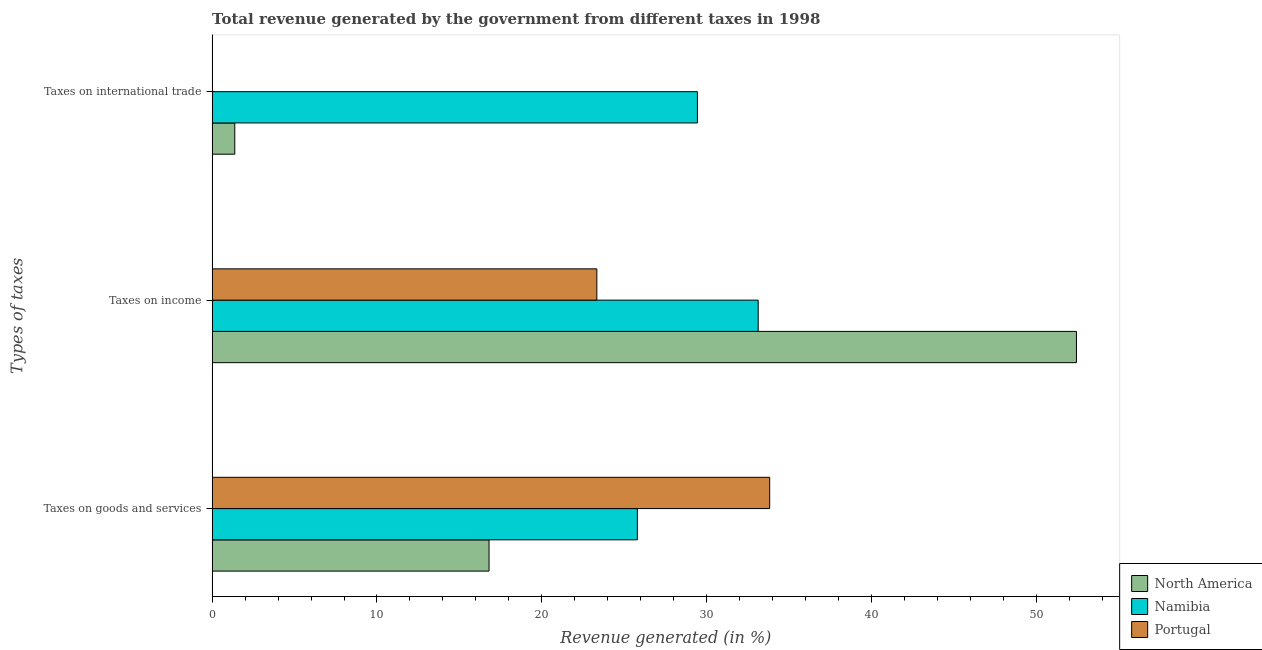Are the number of bars per tick equal to the number of legend labels?
Ensure brevity in your answer.  Yes. Are the number of bars on each tick of the Y-axis equal?
Keep it short and to the point. Yes. How many bars are there on the 3rd tick from the top?
Keep it short and to the point. 3. How many bars are there on the 2nd tick from the bottom?
Offer a very short reply. 3. What is the label of the 1st group of bars from the top?
Ensure brevity in your answer.  Taxes on international trade. What is the percentage of revenue generated by taxes on income in North America?
Provide a short and direct response. 52.43. Across all countries, what is the maximum percentage of revenue generated by tax on international trade?
Your answer should be compact. 29.44. Across all countries, what is the minimum percentage of revenue generated by taxes on goods and services?
Provide a succinct answer. 16.8. What is the total percentage of revenue generated by taxes on income in the graph?
Provide a succinct answer. 108.89. What is the difference between the percentage of revenue generated by taxes on income in North America and that in Portugal?
Offer a very short reply. 29.09. What is the difference between the percentage of revenue generated by tax on international trade in Namibia and the percentage of revenue generated by taxes on income in Portugal?
Keep it short and to the point. 6.1. What is the average percentage of revenue generated by taxes on goods and services per country?
Give a very brief answer. 25.47. What is the difference between the percentage of revenue generated by taxes on income and percentage of revenue generated by taxes on goods and services in Portugal?
Give a very brief answer. -10.49. In how many countries, is the percentage of revenue generated by taxes on income greater than 24 %?
Give a very brief answer. 2. What is the ratio of the percentage of revenue generated by taxes on goods and services in Portugal to that in North America?
Offer a very short reply. 2.01. What is the difference between the highest and the second highest percentage of revenue generated by tax on international trade?
Your response must be concise. 28.06. What is the difference between the highest and the lowest percentage of revenue generated by taxes on income?
Ensure brevity in your answer.  29.09. What does the 2nd bar from the top in Taxes on international trade represents?
Keep it short and to the point. Namibia. Is it the case that in every country, the sum of the percentage of revenue generated by taxes on goods and services and percentage of revenue generated by taxes on income is greater than the percentage of revenue generated by tax on international trade?
Your response must be concise. Yes. How many bars are there?
Make the answer very short. 9. How many countries are there in the graph?
Your answer should be compact. 3. Are the values on the major ticks of X-axis written in scientific E-notation?
Offer a very short reply. No. Does the graph contain any zero values?
Offer a very short reply. No. How many legend labels are there?
Make the answer very short. 3. How are the legend labels stacked?
Provide a succinct answer. Vertical. What is the title of the graph?
Ensure brevity in your answer.  Total revenue generated by the government from different taxes in 1998. Does "Moldova" appear as one of the legend labels in the graph?
Your response must be concise. No. What is the label or title of the X-axis?
Ensure brevity in your answer.  Revenue generated (in %). What is the label or title of the Y-axis?
Keep it short and to the point. Types of taxes. What is the Revenue generated (in %) in North America in Taxes on goods and services?
Keep it short and to the point. 16.8. What is the Revenue generated (in %) of Namibia in Taxes on goods and services?
Make the answer very short. 25.8. What is the Revenue generated (in %) of Portugal in Taxes on goods and services?
Ensure brevity in your answer.  33.82. What is the Revenue generated (in %) in North America in Taxes on income?
Give a very brief answer. 52.43. What is the Revenue generated (in %) of Namibia in Taxes on income?
Provide a short and direct response. 33.13. What is the Revenue generated (in %) in Portugal in Taxes on income?
Provide a succinct answer. 23.34. What is the Revenue generated (in %) of North America in Taxes on international trade?
Provide a succinct answer. 1.37. What is the Revenue generated (in %) in Namibia in Taxes on international trade?
Make the answer very short. 29.44. What is the Revenue generated (in %) in Portugal in Taxes on international trade?
Offer a very short reply. 0.01. Across all Types of taxes, what is the maximum Revenue generated (in %) of North America?
Keep it short and to the point. 52.43. Across all Types of taxes, what is the maximum Revenue generated (in %) in Namibia?
Provide a short and direct response. 33.13. Across all Types of taxes, what is the maximum Revenue generated (in %) in Portugal?
Provide a short and direct response. 33.82. Across all Types of taxes, what is the minimum Revenue generated (in %) in North America?
Make the answer very short. 1.37. Across all Types of taxes, what is the minimum Revenue generated (in %) of Namibia?
Your answer should be very brief. 25.8. Across all Types of taxes, what is the minimum Revenue generated (in %) of Portugal?
Give a very brief answer. 0.01. What is the total Revenue generated (in %) in North America in the graph?
Your answer should be very brief. 70.6. What is the total Revenue generated (in %) in Namibia in the graph?
Your response must be concise. 88.36. What is the total Revenue generated (in %) of Portugal in the graph?
Provide a short and direct response. 57.17. What is the difference between the Revenue generated (in %) in North America in Taxes on goods and services and that in Taxes on income?
Provide a short and direct response. -35.63. What is the difference between the Revenue generated (in %) in Namibia in Taxes on goods and services and that in Taxes on income?
Provide a succinct answer. -7.33. What is the difference between the Revenue generated (in %) of Portugal in Taxes on goods and services and that in Taxes on income?
Ensure brevity in your answer.  10.49. What is the difference between the Revenue generated (in %) of North America in Taxes on goods and services and that in Taxes on international trade?
Make the answer very short. 15.42. What is the difference between the Revenue generated (in %) in Namibia in Taxes on goods and services and that in Taxes on international trade?
Make the answer very short. -3.64. What is the difference between the Revenue generated (in %) in Portugal in Taxes on goods and services and that in Taxes on international trade?
Give a very brief answer. 33.82. What is the difference between the Revenue generated (in %) of North America in Taxes on income and that in Taxes on international trade?
Offer a terse response. 51.06. What is the difference between the Revenue generated (in %) of Namibia in Taxes on income and that in Taxes on international trade?
Your answer should be compact. 3.69. What is the difference between the Revenue generated (in %) in Portugal in Taxes on income and that in Taxes on international trade?
Offer a terse response. 23.33. What is the difference between the Revenue generated (in %) of North America in Taxes on goods and services and the Revenue generated (in %) of Namibia in Taxes on income?
Your answer should be very brief. -16.33. What is the difference between the Revenue generated (in %) in North America in Taxes on goods and services and the Revenue generated (in %) in Portugal in Taxes on income?
Your answer should be compact. -6.54. What is the difference between the Revenue generated (in %) in Namibia in Taxes on goods and services and the Revenue generated (in %) in Portugal in Taxes on income?
Your answer should be compact. 2.46. What is the difference between the Revenue generated (in %) of North America in Taxes on goods and services and the Revenue generated (in %) of Namibia in Taxes on international trade?
Your response must be concise. -12.64. What is the difference between the Revenue generated (in %) of North America in Taxes on goods and services and the Revenue generated (in %) of Portugal in Taxes on international trade?
Your answer should be very brief. 16.79. What is the difference between the Revenue generated (in %) in Namibia in Taxes on goods and services and the Revenue generated (in %) in Portugal in Taxes on international trade?
Give a very brief answer. 25.79. What is the difference between the Revenue generated (in %) of North America in Taxes on income and the Revenue generated (in %) of Namibia in Taxes on international trade?
Provide a short and direct response. 22.99. What is the difference between the Revenue generated (in %) of North America in Taxes on income and the Revenue generated (in %) of Portugal in Taxes on international trade?
Keep it short and to the point. 52.43. What is the difference between the Revenue generated (in %) of Namibia in Taxes on income and the Revenue generated (in %) of Portugal in Taxes on international trade?
Offer a terse response. 33.12. What is the average Revenue generated (in %) of North America per Types of taxes?
Your answer should be very brief. 23.53. What is the average Revenue generated (in %) in Namibia per Types of taxes?
Keep it short and to the point. 29.45. What is the average Revenue generated (in %) of Portugal per Types of taxes?
Offer a terse response. 19.06. What is the difference between the Revenue generated (in %) of North America and Revenue generated (in %) of Namibia in Taxes on goods and services?
Offer a very short reply. -9. What is the difference between the Revenue generated (in %) in North America and Revenue generated (in %) in Portugal in Taxes on goods and services?
Make the answer very short. -17.02. What is the difference between the Revenue generated (in %) in Namibia and Revenue generated (in %) in Portugal in Taxes on goods and services?
Offer a terse response. -8.03. What is the difference between the Revenue generated (in %) of North America and Revenue generated (in %) of Namibia in Taxes on income?
Give a very brief answer. 19.31. What is the difference between the Revenue generated (in %) of North America and Revenue generated (in %) of Portugal in Taxes on income?
Offer a very short reply. 29.09. What is the difference between the Revenue generated (in %) of Namibia and Revenue generated (in %) of Portugal in Taxes on income?
Provide a short and direct response. 9.79. What is the difference between the Revenue generated (in %) of North America and Revenue generated (in %) of Namibia in Taxes on international trade?
Your answer should be compact. -28.06. What is the difference between the Revenue generated (in %) of North America and Revenue generated (in %) of Portugal in Taxes on international trade?
Offer a terse response. 1.37. What is the difference between the Revenue generated (in %) in Namibia and Revenue generated (in %) in Portugal in Taxes on international trade?
Provide a succinct answer. 29.43. What is the ratio of the Revenue generated (in %) in North America in Taxes on goods and services to that in Taxes on income?
Offer a very short reply. 0.32. What is the ratio of the Revenue generated (in %) in Namibia in Taxes on goods and services to that in Taxes on income?
Provide a short and direct response. 0.78. What is the ratio of the Revenue generated (in %) in Portugal in Taxes on goods and services to that in Taxes on income?
Offer a terse response. 1.45. What is the ratio of the Revenue generated (in %) in North America in Taxes on goods and services to that in Taxes on international trade?
Ensure brevity in your answer.  12.23. What is the ratio of the Revenue generated (in %) of Namibia in Taxes on goods and services to that in Taxes on international trade?
Ensure brevity in your answer.  0.88. What is the ratio of the Revenue generated (in %) in Portugal in Taxes on goods and services to that in Taxes on international trade?
Your answer should be compact. 5415.9. What is the ratio of the Revenue generated (in %) in North America in Taxes on income to that in Taxes on international trade?
Offer a terse response. 38.16. What is the ratio of the Revenue generated (in %) in Namibia in Taxes on income to that in Taxes on international trade?
Keep it short and to the point. 1.13. What is the ratio of the Revenue generated (in %) of Portugal in Taxes on income to that in Taxes on international trade?
Make the answer very short. 3736.92. What is the difference between the highest and the second highest Revenue generated (in %) in North America?
Offer a terse response. 35.63. What is the difference between the highest and the second highest Revenue generated (in %) in Namibia?
Ensure brevity in your answer.  3.69. What is the difference between the highest and the second highest Revenue generated (in %) in Portugal?
Offer a terse response. 10.49. What is the difference between the highest and the lowest Revenue generated (in %) in North America?
Offer a very short reply. 51.06. What is the difference between the highest and the lowest Revenue generated (in %) in Namibia?
Offer a terse response. 7.33. What is the difference between the highest and the lowest Revenue generated (in %) of Portugal?
Keep it short and to the point. 33.82. 